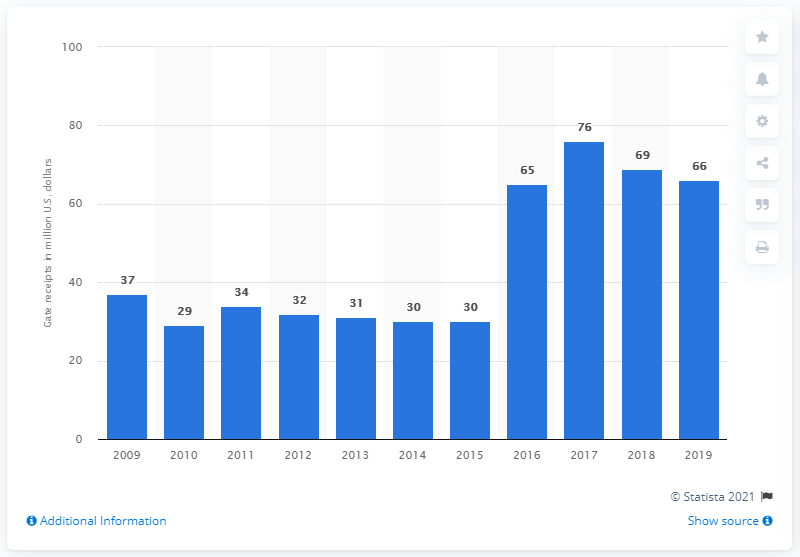Identify some key points in this picture. The gate receipts of the Cleveland Indians in 2019 were 66. 